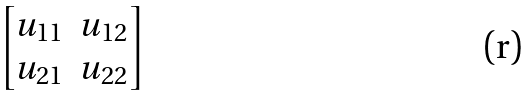Convert formula to latex. <formula><loc_0><loc_0><loc_500><loc_500>\begin{bmatrix} u _ { 1 1 } & u _ { 1 2 } \\ u _ { 2 1 } & u _ { 2 2 } \end{bmatrix}</formula> 